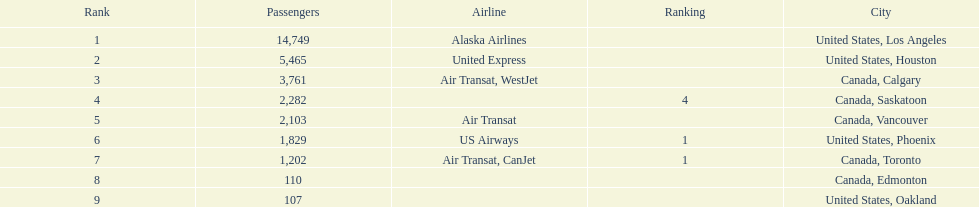Which canadian city had the most passengers traveling from manzanillo international airport in 2013? Calgary. 